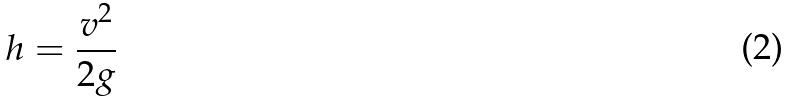Convert formula to latex. <formula><loc_0><loc_0><loc_500><loc_500>h = \frac { v ^ { 2 } } { 2 g }</formula> 